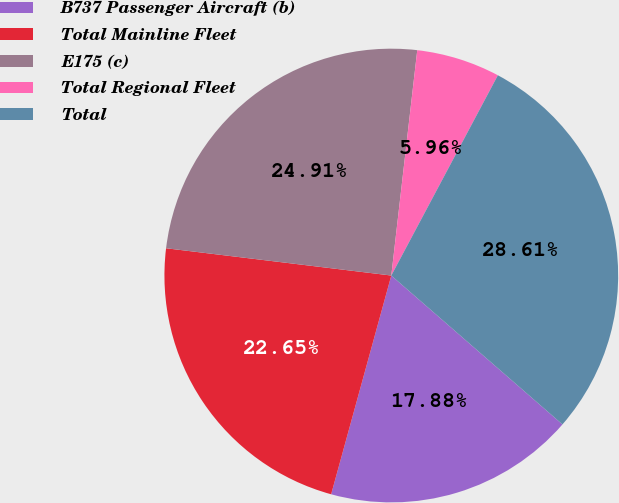Convert chart. <chart><loc_0><loc_0><loc_500><loc_500><pie_chart><fcel>B737 Passenger Aircraft (b)<fcel>Total Mainline Fleet<fcel>E175 (c)<fcel>Total Regional Fleet<fcel>Total<nl><fcel>17.88%<fcel>22.65%<fcel>24.91%<fcel>5.96%<fcel>28.61%<nl></chart> 